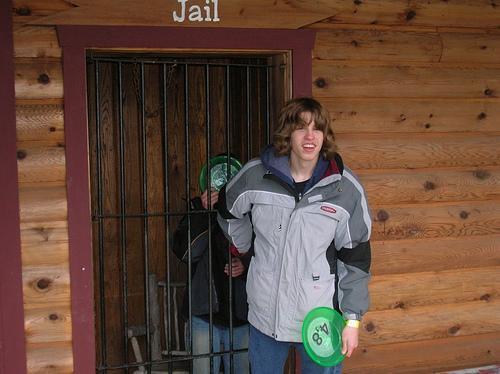How many people are visible?
Give a very brief answer. 2. 